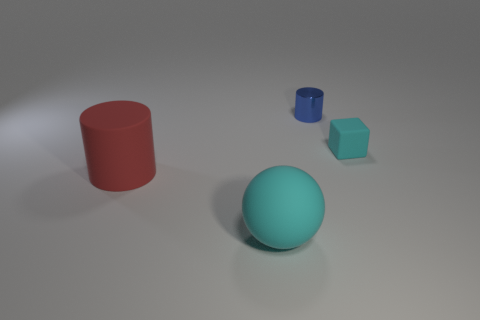What is the shape of the cyan rubber thing behind the big red matte object?
Ensure brevity in your answer.  Cube. What number of red objects are large matte spheres or large matte things?
Give a very brief answer. 1. There is a small thing that is made of the same material as the big red cylinder; what is its color?
Keep it short and to the point. Cyan. There is a large sphere; is it the same color as the object that is behind the tiny cyan matte thing?
Provide a short and direct response. No. There is a thing that is both on the right side of the ball and in front of the tiny cylinder; what is its color?
Offer a terse response. Cyan. There is a tiny matte cube; how many cyan rubber things are left of it?
Offer a terse response. 1. What number of things are large red cylinders or big red things on the left side of the small cyan rubber thing?
Your answer should be compact. 1. There is a cyan object on the right side of the cyan sphere; are there any big red things behind it?
Your answer should be very brief. No. What is the color of the matte thing on the right side of the blue metallic object?
Provide a succinct answer. Cyan. Are there the same number of cylinders that are on the right side of the blue shiny object and blue things?
Offer a very short reply. No. 